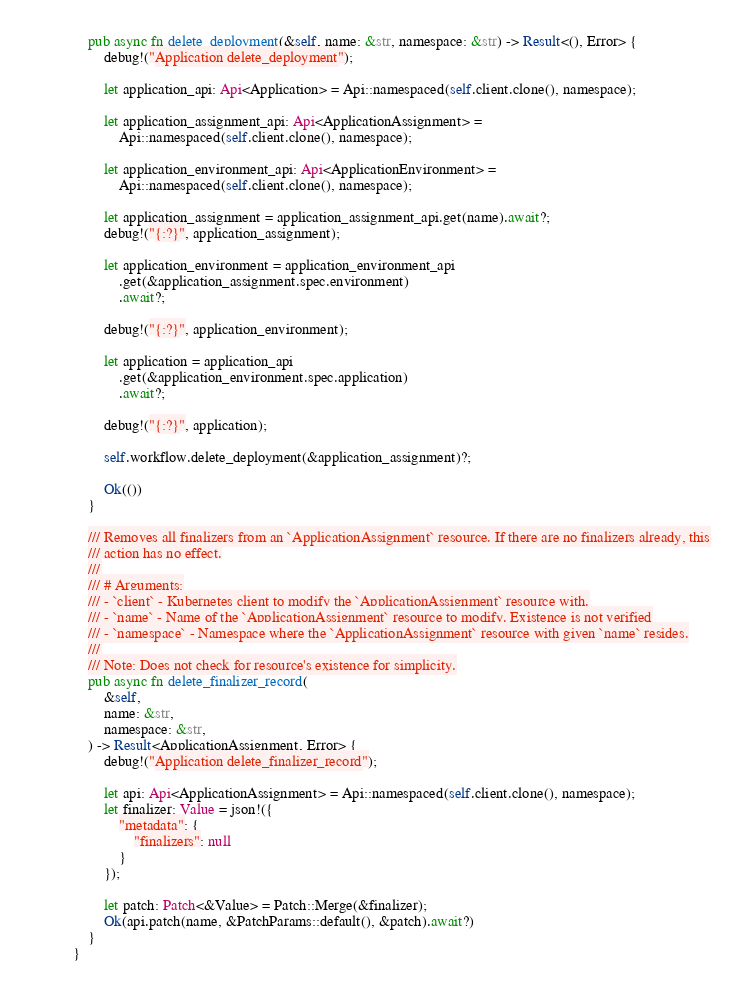<code> <loc_0><loc_0><loc_500><loc_500><_Rust_>    pub async fn delete_deployment(&self, name: &str, namespace: &str) -> Result<(), Error> {
        debug!("Application delete_deployment");

        let application_api: Api<Application> = Api::namespaced(self.client.clone(), namespace);

        let application_assignment_api: Api<ApplicationAssignment> =
            Api::namespaced(self.client.clone(), namespace);

        let application_environment_api: Api<ApplicationEnvironment> =
            Api::namespaced(self.client.clone(), namespace);

        let application_assignment = application_assignment_api.get(name).await?;
        debug!("{:?}", application_assignment);

        let application_environment = application_environment_api
            .get(&application_assignment.spec.environment)
            .await?;

        debug!("{:?}", application_environment);

        let application = application_api
            .get(&application_environment.spec.application)
            .await?;

        debug!("{:?}", application);

        self.workflow.delete_deployment(&application_assignment)?;

        Ok(())
    }

    /// Removes all finalizers from an `ApplicationAssignment` resource. If there are no finalizers already, this
    /// action has no effect.
    ///
    /// # Arguments:
    /// - `client` - Kubernetes client to modify the `ApplicationAssignment` resource with.
    /// - `name` - Name of the `ApplicationAssignment` resource to modify. Existence is not verified
    /// - `namespace` - Namespace where the `ApplicationAssignment` resource with given `name` resides.
    ///
    /// Note: Does not check for resource's existence for simplicity.
    pub async fn delete_finalizer_record(
        &self,
        name: &str,
        namespace: &str,
    ) -> Result<ApplicationAssignment, Error> {
        debug!("Application delete_finalizer_record");

        let api: Api<ApplicationAssignment> = Api::namespaced(self.client.clone(), namespace);
        let finalizer: Value = json!({
            "metadata": {
                "finalizers": null
            }
        });

        let patch: Patch<&Value> = Patch::Merge(&finalizer);
        Ok(api.patch(name, &PatchParams::default(), &patch).await?)
    }
}
</code> 